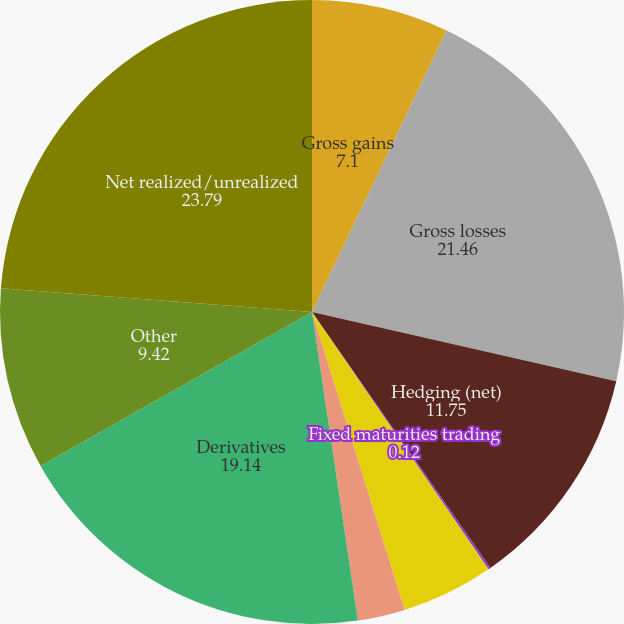Convert chart. <chart><loc_0><loc_0><loc_500><loc_500><pie_chart><fcel>Gross gains<fcel>Gross losses<fcel>Hedging (net)<fcel>Fixed maturities trading<fcel>Equity securities trading<fcel>Mortgage loans<fcel>Derivatives<fcel>Other<fcel>Net realized/unrealized<nl><fcel>7.1%<fcel>21.46%<fcel>11.75%<fcel>0.12%<fcel>4.77%<fcel>2.45%<fcel>19.14%<fcel>9.42%<fcel>23.79%<nl></chart> 